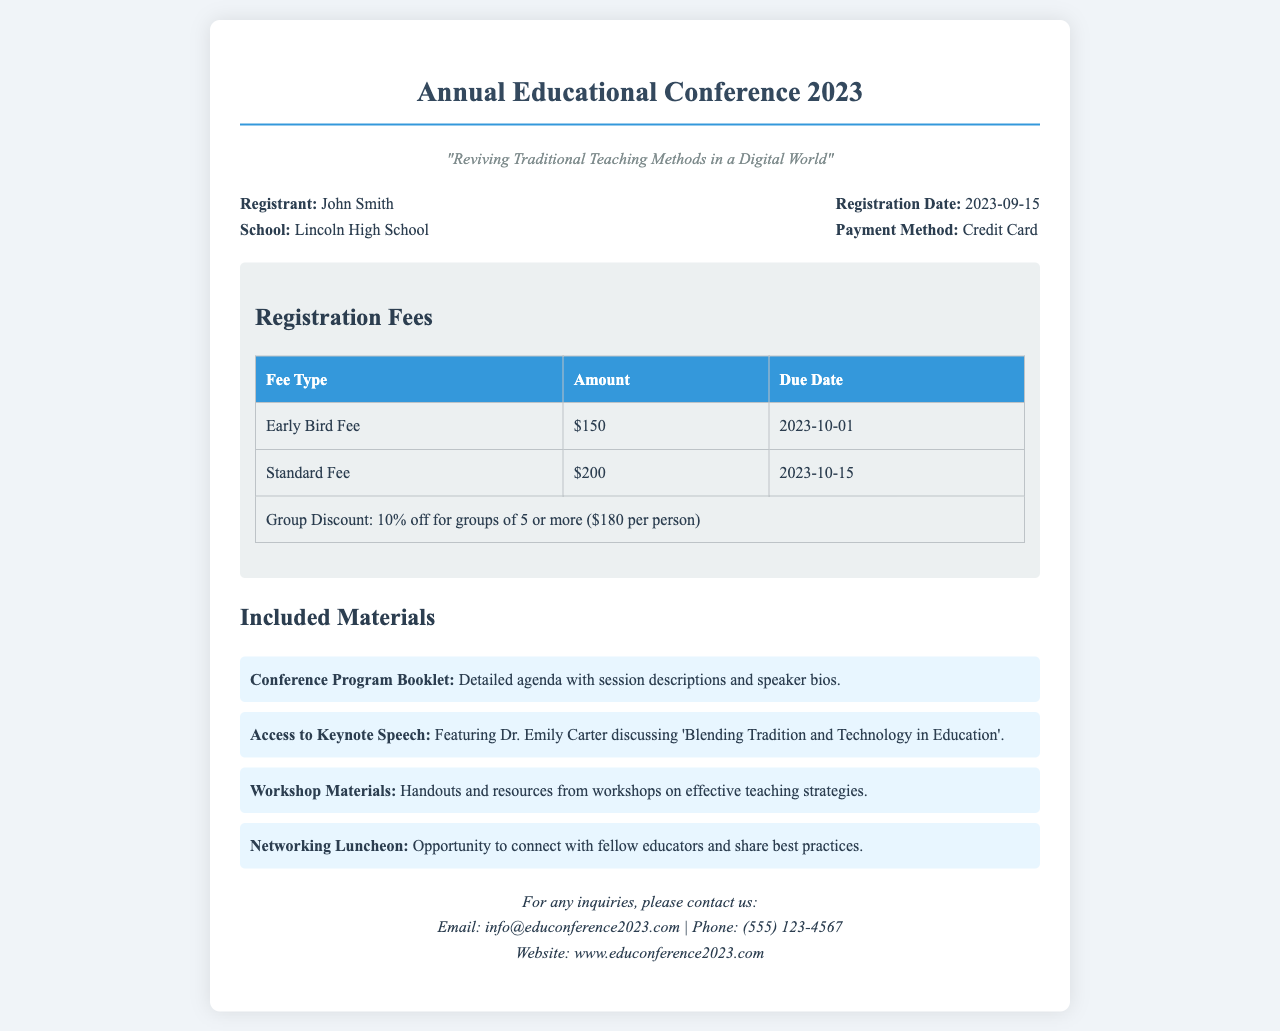What is the registrant's name? The registrant's name is mentioned in the receipt under the "Registrant" section.
Answer: John Smith What is the theme of the conference? The theme is stated clearly below the title of the conference in the document.
Answer: "Reviving Traditional Teaching Methods in a Digital World" When is the Early Bird Fee due? The due date for the Early Bird Fee is provided in the registration fees section of the document.
Answer: 2023-10-01 What is the Standard Fee amount? The amount for the Standard Fee can be found in the registration fees table.
Answer: $200 What discount is offered for group registrations? The discount information is provided in the registration fees table of the document.
Answer: 10% off What material discusses blending tradition and technology? The document lists the materials included and specifies the keynote speech related to the topic.
Answer: Keynote Speech What is included in the networking luncheon? The networking luncheon is mentioned in the included materials list, describing its purpose.
Answer: Opportunity to connect with fellow educators What payment method was used for registration? The payment method is specified in the receipt header section.
Answer: Credit Card How can inquiries be made? The contact information section outlines how to make inquiries.
Answer: Email: info@educonference2023.com 